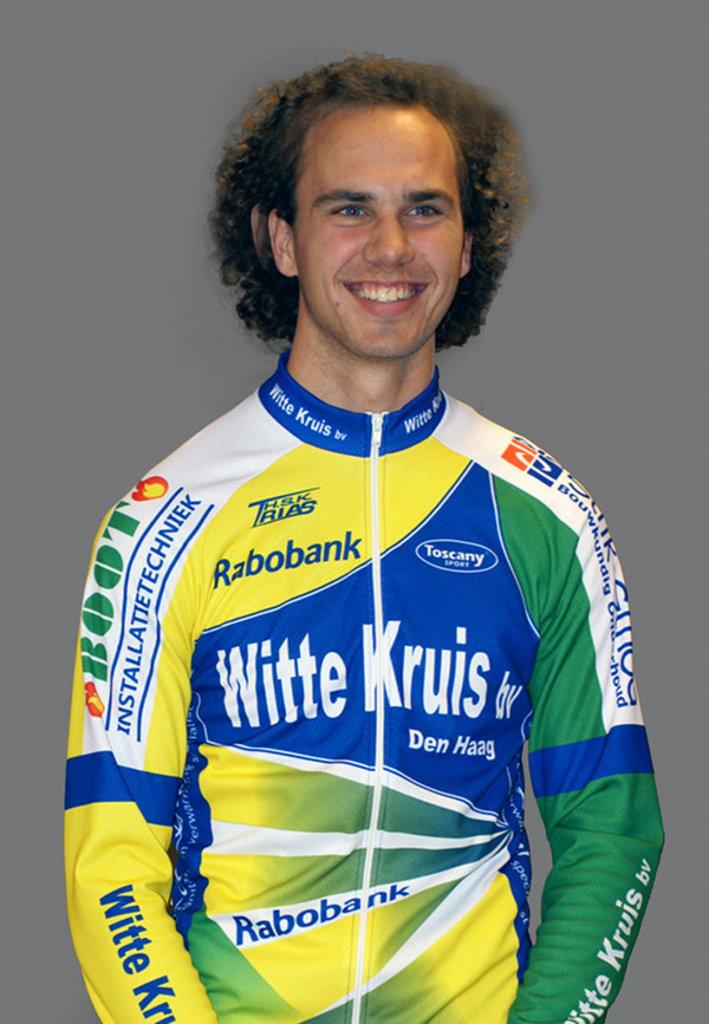Provide a one-sentence caption for the provided image. A man is wearing a jacket with multiple sponsors, including Toscany Sport and Rabobank. 